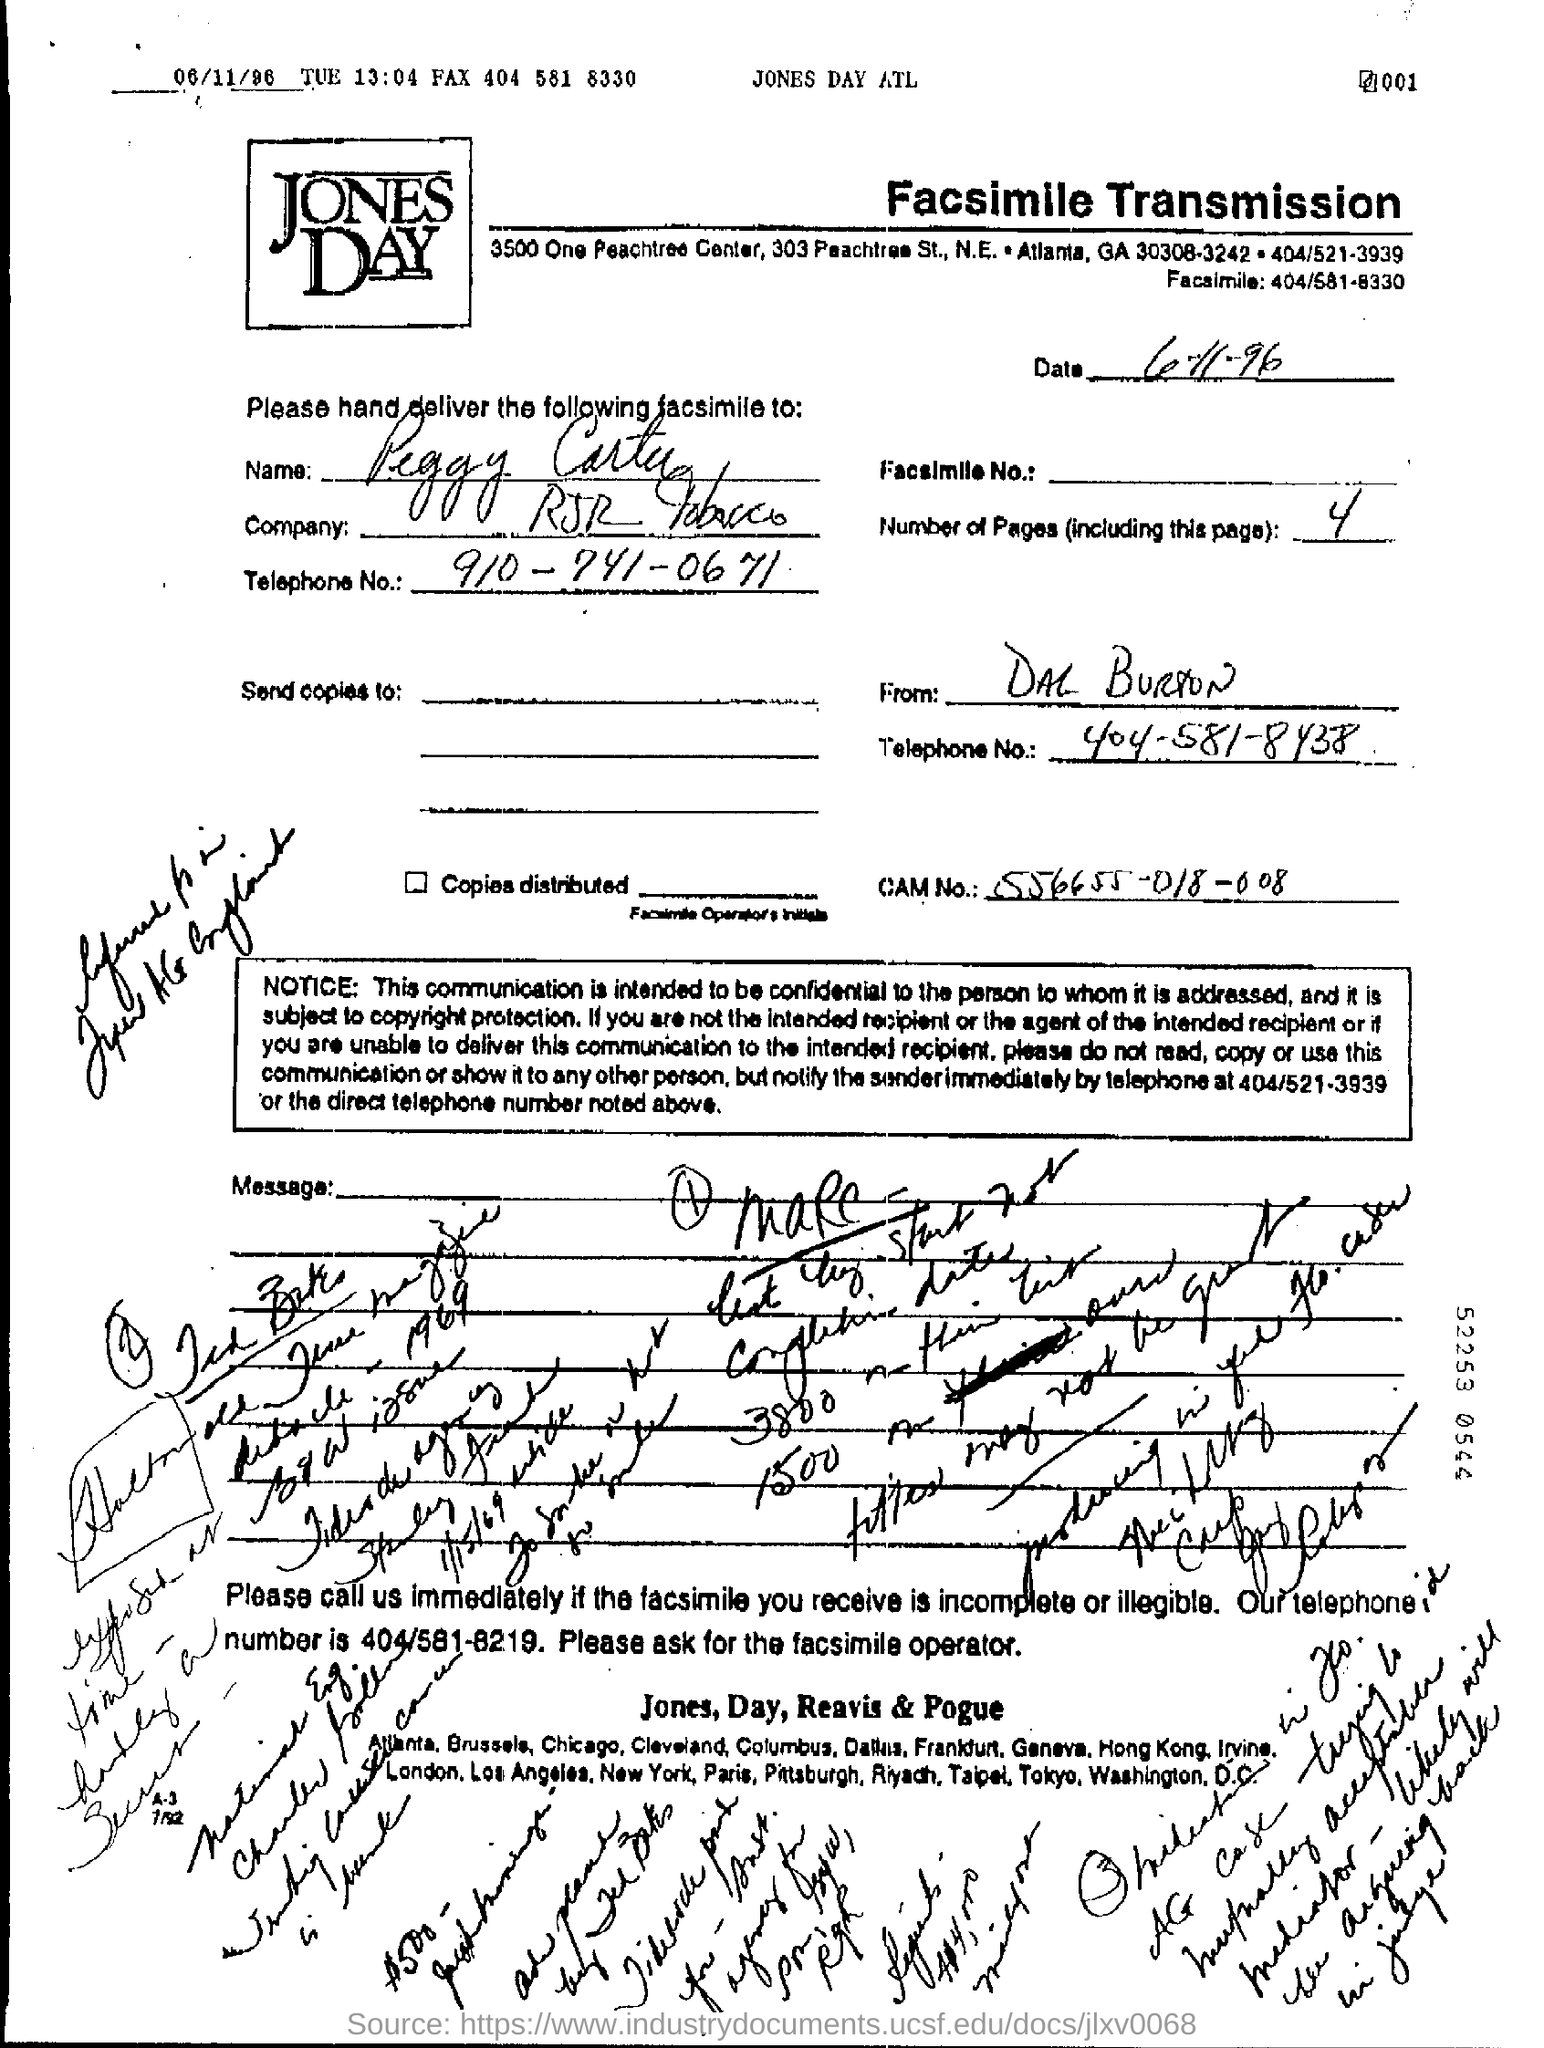What is the date mentioned in the page ?
Give a very brief answer. 06/11/96. How many number of pages are there including this page ?
Give a very brief answer. 4. 